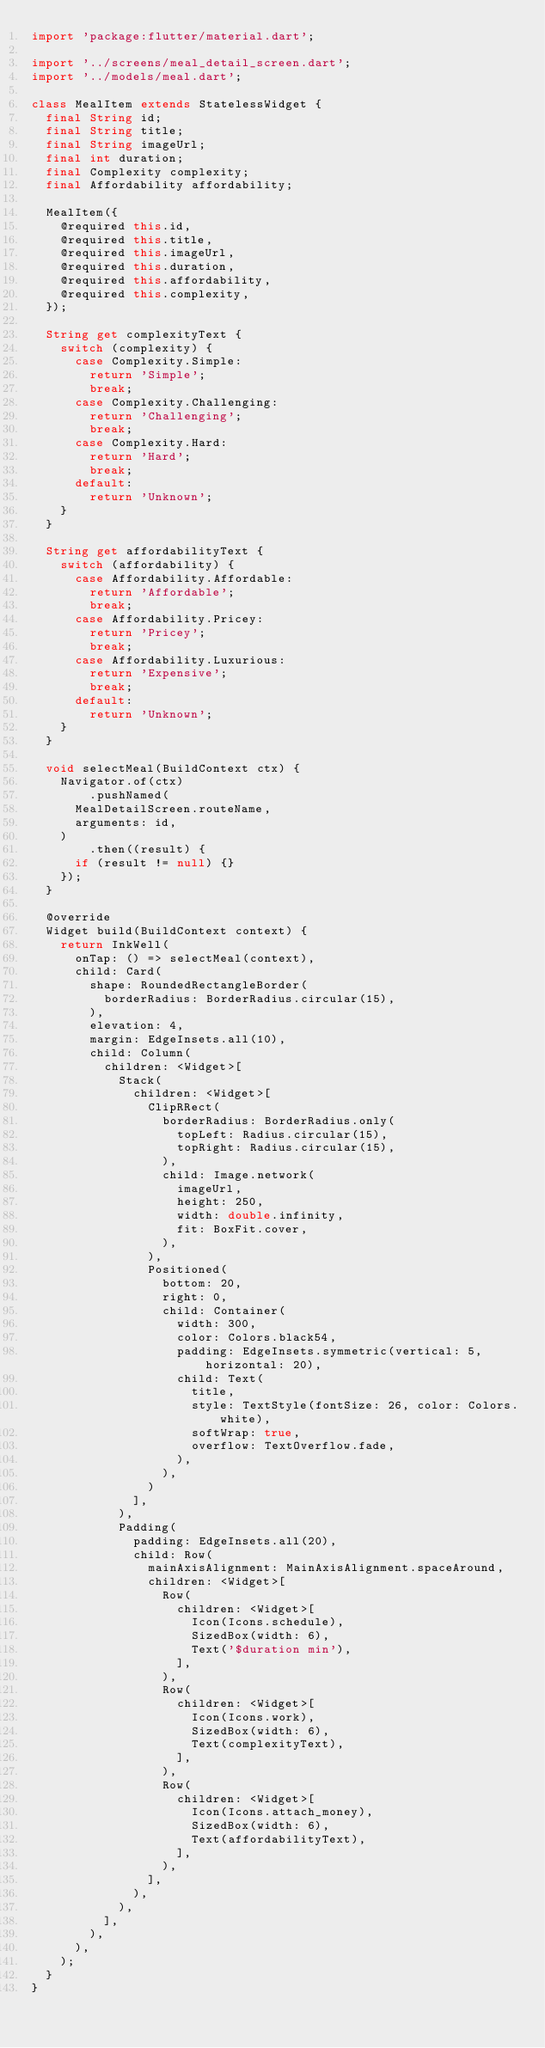<code> <loc_0><loc_0><loc_500><loc_500><_Dart_>import 'package:flutter/material.dart';

import '../screens/meal_detail_screen.dart';
import '../models/meal.dart';

class MealItem extends StatelessWidget {
  final String id;
  final String title;
  final String imageUrl;
  final int duration;
  final Complexity complexity;
  final Affordability affordability;

  MealItem({
    @required this.id,
    @required this.title,
    @required this.imageUrl,
    @required this.duration,
    @required this.affordability,
    @required this.complexity,
  });

  String get complexityText {
    switch (complexity) {
      case Complexity.Simple:
        return 'Simple';
        break;
      case Complexity.Challenging:
        return 'Challenging';
        break;
      case Complexity.Hard:
        return 'Hard';
        break;
      default:
        return 'Unknown';
    }
  }

  String get affordabilityText {
    switch (affordability) {
      case Affordability.Affordable:
        return 'Affordable';
        break;
      case Affordability.Pricey:
        return 'Pricey';
        break;
      case Affordability.Luxurious:
        return 'Expensive';
        break;
      default:
        return 'Unknown';
    }
  }

  void selectMeal(BuildContext ctx) {
    Navigator.of(ctx)
        .pushNamed(
      MealDetailScreen.routeName,
      arguments: id,
    )
        .then((result) {
      if (result != null) {}
    });
  }

  @override
  Widget build(BuildContext context) {
    return InkWell(
      onTap: () => selectMeal(context),
      child: Card(
        shape: RoundedRectangleBorder(
          borderRadius: BorderRadius.circular(15),
        ),
        elevation: 4,
        margin: EdgeInsets.all(10),
        child: Column(
          children: <Widget>[
            Stack(
              children: <Widget>[
                ClipRRect(
                  borderRadius: BorderRadius.only(
                    topLeft: Radius.circular(15),
                    topRight: Radius.circular(15),
                  ),
                  child: Image.network(
                    imageUrl,
                    height: 250,
                    width: double.infinity,
                    fit: BoxFit.cover,
                  ),
                ),
                Positioned(
                  bottom: 20,
                  right: 0,
                  child: Container(
                    width: 300,
                    color: Colors.black54,
                    padding: EdgeInsets.symmetric(vertical: 5, horizontal: 20),
                    child: Text(
                      title,
                      style: TextStyle(fontSize: 26, color: Colors.white),
                      softWrap: true,
                      overflow: TextOverflow.fade,
                    ),
                  ),
                )
              ],
            ),
            Padding(
              padding: EdgeInsets.all(20),
              child: Row(
                mainAxisAlignment: MainAxisAlignment.spaceAround,
                children: <Widget>[
                  Row(
                    children: <Widget>[
                      Icon(Icons.schedule),
                      SizedBox(width: 6),
                      Text('$duration min'),
                    ],
                  ),
                  Row(
                    children: <Widget>[
                      Icon(Icons.work),
                      SizedBox(width: 6),
                      Text(complexityText),
                    ],
                  ),
                  Row(
                    children: <Widget>[
                      Icon(Icons.attach_money),
                      SizedBox(width: 6),
                      Text(affordabilityText),
                    ],
                  ),
                ],
              ),
            ),
          ],
        ),
      ),
    );
  }
}
</code> 